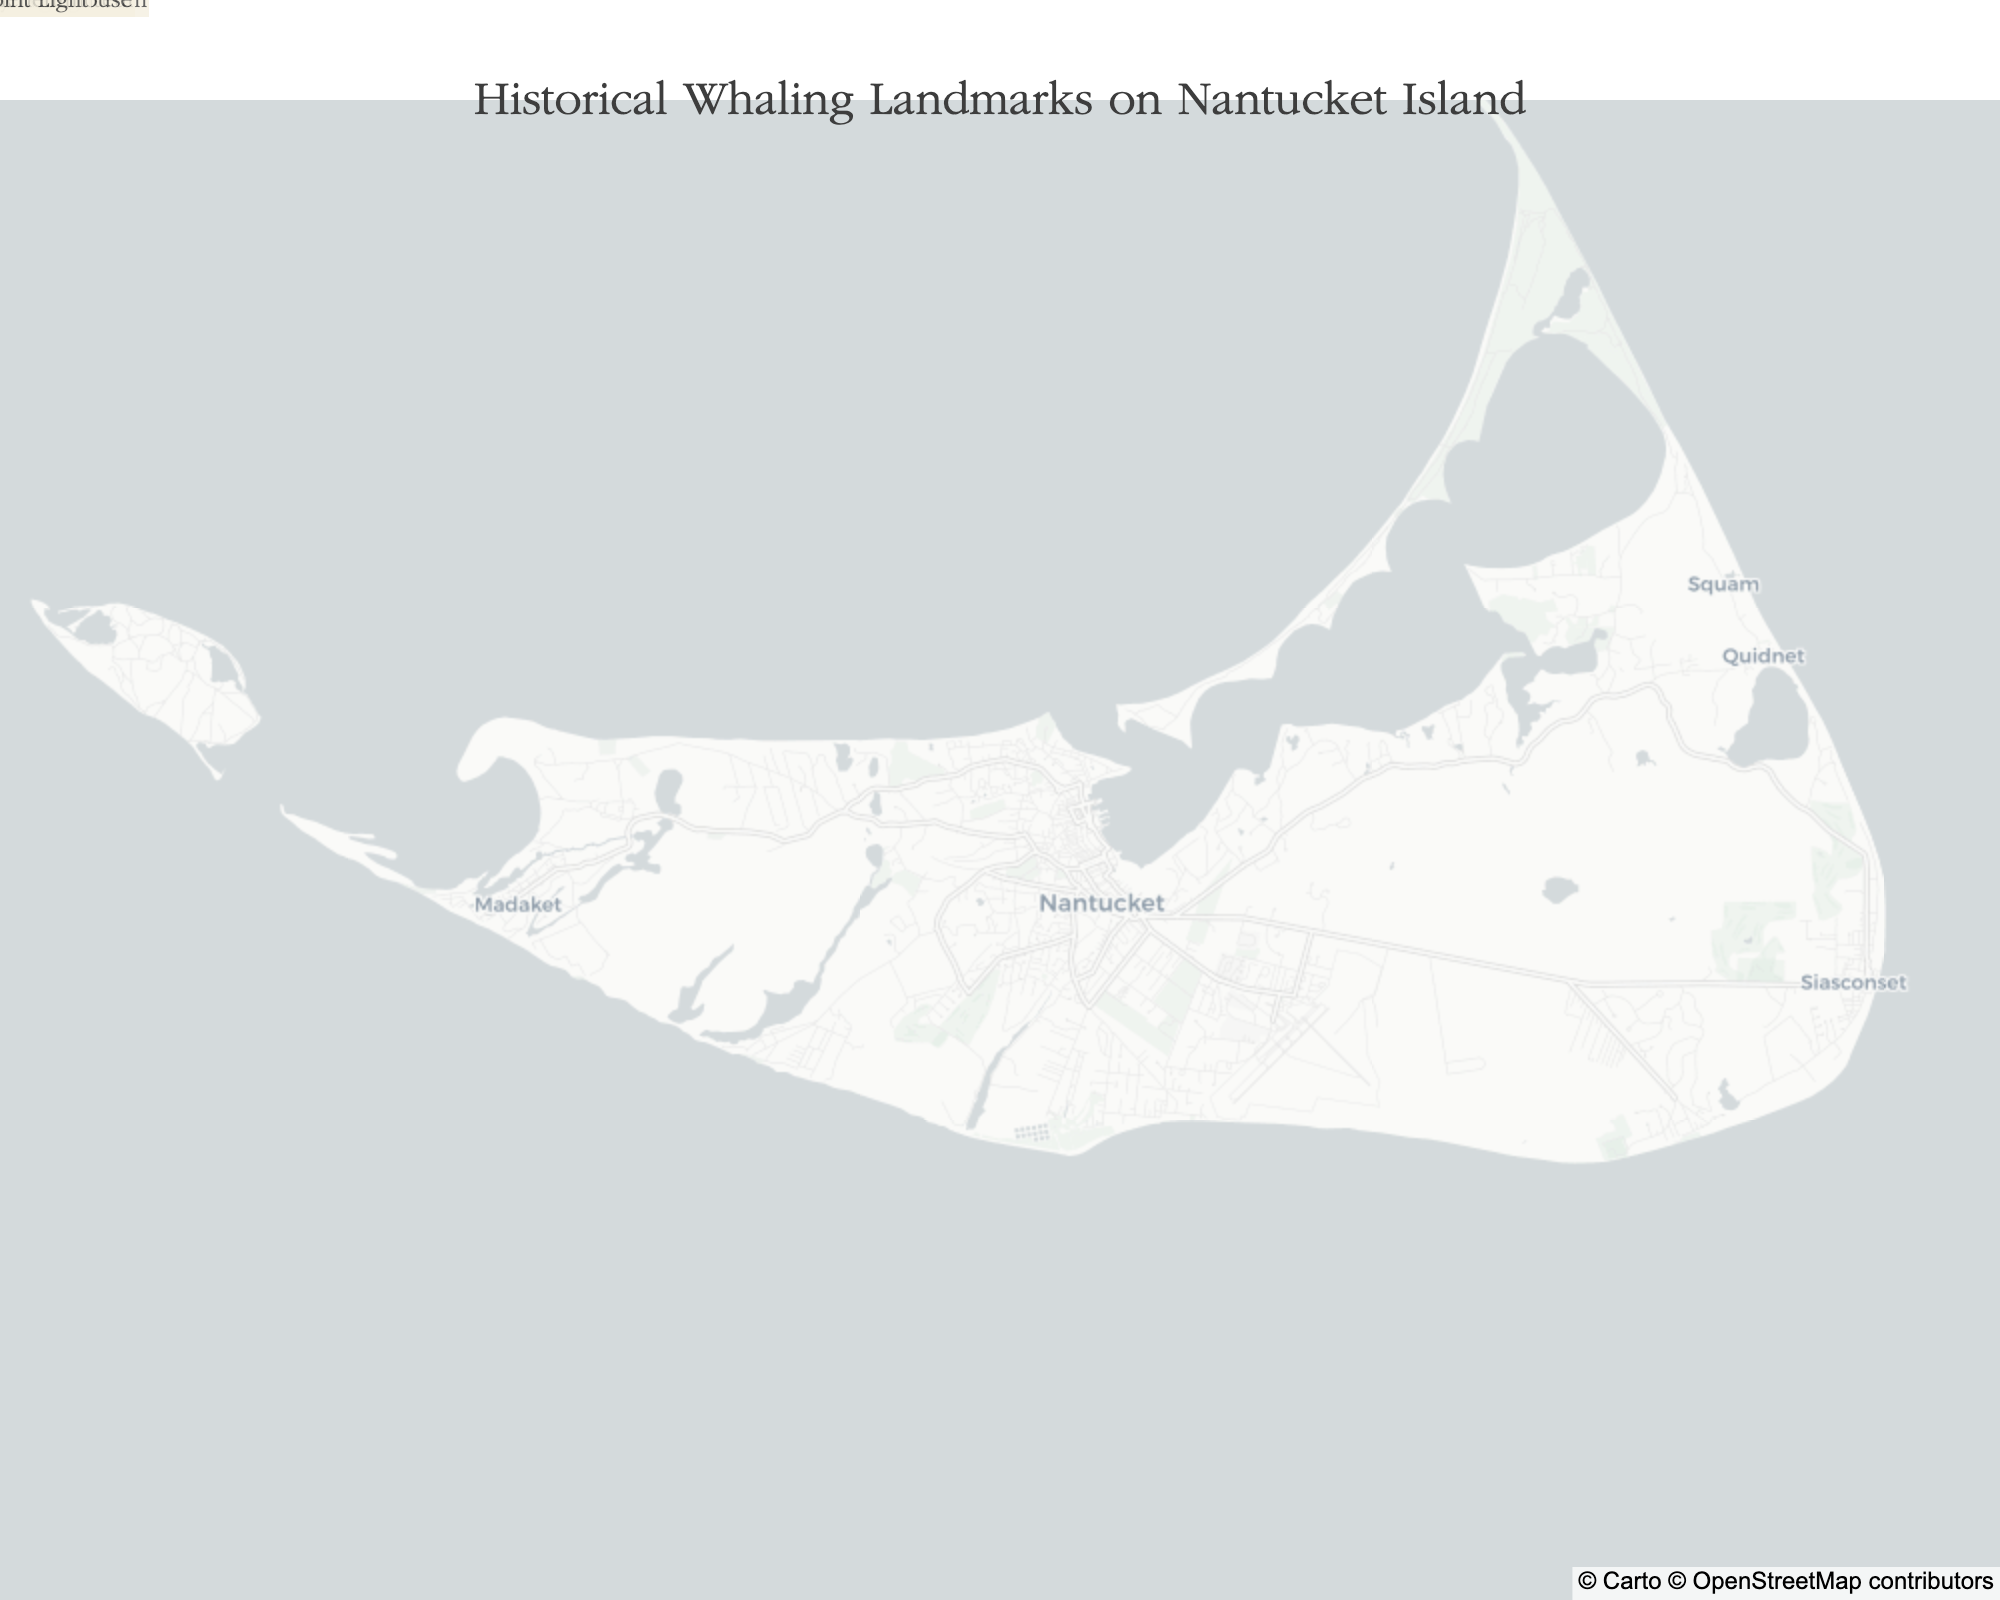What's the title of the figure? The title of the map is often displayed prominently at the top of the figure. In this case, it reads "Historical Whaling Landmarks on Nantucket Island."
Answer: Historical Whaling Landmarks on Nantucket Island How many historical locations related to the whaling industry are mapped on Nantucket Island? By counting the number of markers or annotations on the map, we can determine the total number of historical locations. There are seven locations.
Answer: Seven Which historical landmark is closest to the center of the island? By observing the geographic positions of the landmarks, we can identify the one that is most centrally located. The Nantucket Whaling Museum appears to be closest to the center.
Answer: Nantucket Whaling Museum Which lighthouse has been guiding ships into Nantucket Harbor since 1746? The descriptions associated with each marker provide detailed information. Brant Point Light is noted for guiding ships into Nantucket Harbor since 1746.
Answer: Brant Point Light What is the westernmost historical location related to whaling? By examining the map, we can determine the westernmost point based on longitude values. Madaket, located in the historic fishing village, is the westernmost location.
Answer: Madaket Which landmark was a former candle factory turned into a museum? From the descriptions provided, the Nantucket Whaling Museum is identified as a former candle factory turned museum that showcases whaling artifacts and history.
Answer: Nantucket Whaling Museum What is the most northern landmark on this map? The northernmost point can be determined by comparing the latitude values of the locations. Brant Point Light is the northernmost landmark.
Answer: Brant Point Light Which location is a Greek Revival mansion of a whaling merchant? According to the descriptions, the Hadwen House is noted as the Greek Revival mansion of whaling merchant William Hadwen.
Answer: Hadwen House What's the difference in latitude between Sankaty Head Light and Madaket? The latitude of Sankaty Head Light is 41.2700 and Madaket is 41.2539. The difference is 41.2700 - 41.2539 = 0.0161 degrees.
Answer: 0.0161 degrees Which location is both a public library and has an extensive whaling history collection? According to the descriptions, The Atheneum is noted as a public library founded in 1834 with an extensive whaling history collection.
Answer: The Atheneum 